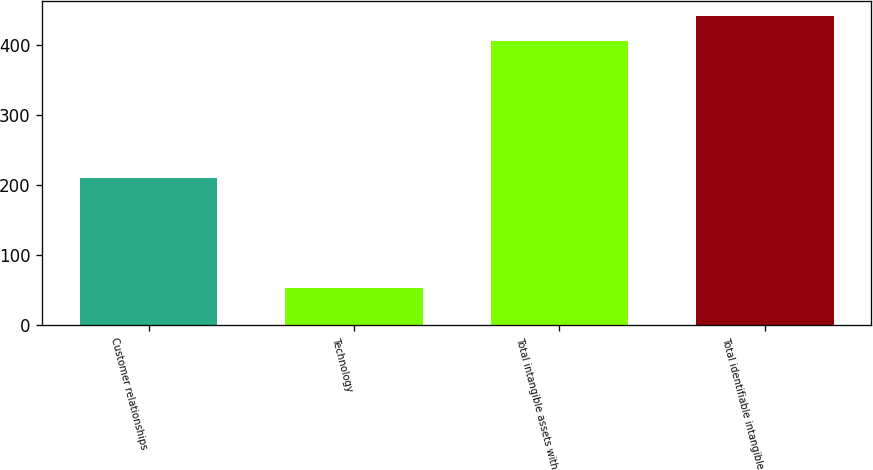Convert chart. <chart><loc_0><loc_0><loc_500><loc_500><bar_chart><fcel>Customer relationships<fcel>Technology<fcel>Total intangible assets with<fcel>Total identifiable intangible<nl><fcel>210.8<fcel>53.2<fcel>406.9<fcel>442.27<nl></chart> 